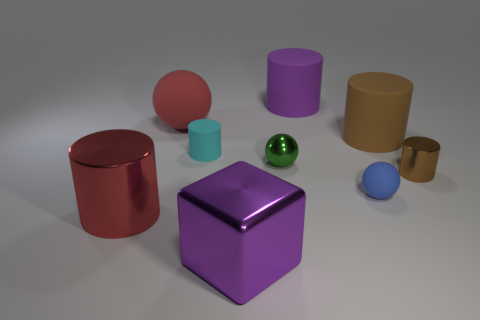There is a cylinder behind the matte sphere behind the brown matte thing; what is its material?
Give a very brief answer. Rubber. Is the number of big things to the right of the small rubber cylinder greater than the number of large metal objects on the right side of the tiny shiny ball?
Give a very brief answer. Yes. What size is the brown matte cylinder?
Provide a succinct answer. Large. There is a shiny cylinder that is to the left of the large shiny cube; does it have the same color as the big sphere?
Your answer should be very brief. Yes. Are there any other things that have the same shape as the tiny brown shiny object?
Provide a short and direct response. Yes. Are there any big rubber objects that are in front of the red object that is behind the tiny cyan matte thing?
Offer a terse response. Yes. Are there fewer small matte spheres that are behind the tiny rubber cylinder than big things to the left of the large red sphere?
Give a very brief answer. Yes. What is the size of the matte ball that is behind the big matte cylinder in front of the matte ball behind the small blue ball?
Your answer should be very brief. Large. There is a red cylinder in front of the purple rubber cylinder; is it the same size as the tiny blue object?
Offer a very short reply. No. What number of other things are there of the same material as the tiny cyan thing
Offer a terse response. 4. 